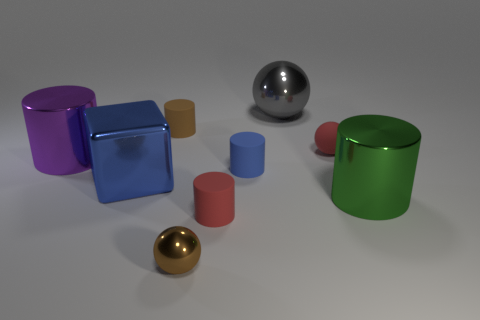Are there any other things that are the same size as the green cylinder?
Give a very brief answer. Yes. Is there another tiny shiny object of the same shape as the purple object?
Keep it short and to the point. No. How many tiny brown matte things have the same shape as the big green thing?
Provide a short and direct response. 1. Does the large cube have the same color as the rubber ball?
Your answer should be very brief. No. Are there fewer large green metallic things than brown objects?
Provide a short and direct response. Yes. There is a brown object in front of the green shiny cylinder; what is its material?
Provide a succinct answer. Metal. What material is the blue thing that is the same size as the gray sphere?
Offer a very short reply. Metal. There is a big blue block that is in front of the tiny ball to the right of the shiny thing that is behind the big purple cylinder; what is it made of?
Ensure brevity in your answer.  Metal. There is a metal ball that is to the left of the gray metallic object; does it have the same size as the big purple object?
Make the answer very short. No. Is the number of metallic cylinders greater than the number of big blue rubber blocks?
Provide a succinct answer. Yes. 